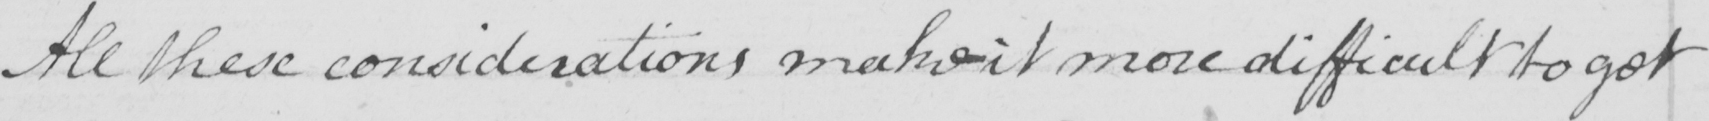Please transcribe the handwritten text in this image. All these considerations make it more difficult to get 